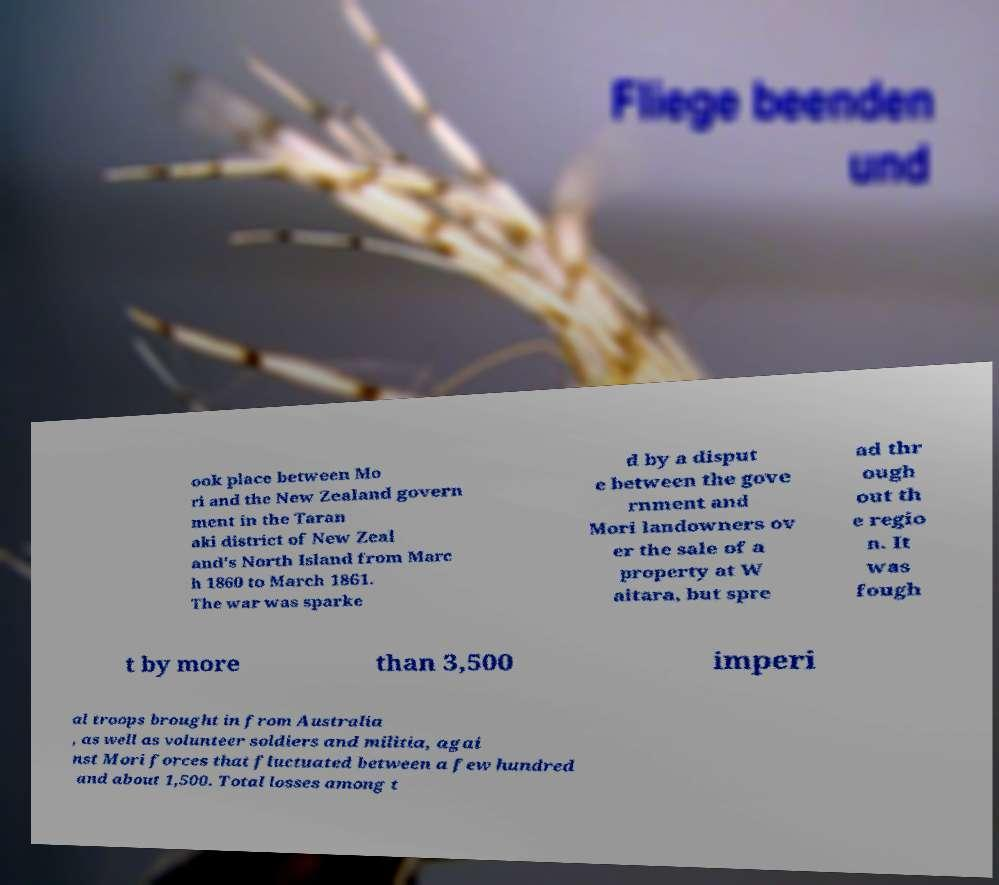Can you accurately transcribe the text from the provided image for me? ook place between Mo ri and the New Zealand govern ment in the Taran aki district of New Zeal and's North Island from Marc h 1860 to March 1861. The war was sparke d by a disput e between the gove rnment and Mori landowners ov er the sale of a property at W aitara, but spre ad thr ough out th e regio n. It was fough t by more than 3,500 imperi al troops brought in from Australia , as well as volunteer soldiers and militia, agai nst Mori forces that fluctuated between a few hundred and about 1,500. Total losses among t 